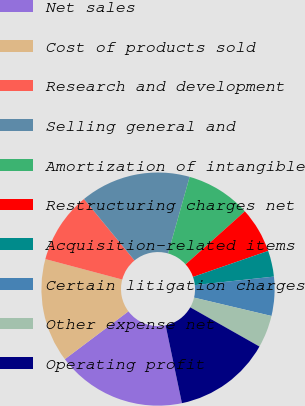<chart> <loc_0><loc_0><loc_500><loc_500><pie_chart><fcel>Net sales<fcel>Cost of products sold<fcel>Research and development<fcel>Selling general and<fcel>Amortization of intangible<fcel>Restructuring charges net<fcel>Acquisition-related items<fcel>Certain litigation charges<fcel>Other expense net<fcel>Operating profit<nl><fcel>18.02%<fcel>14.41%<fcel>9.91%<fcel>15.32%<fcel>9.01%<fcel>6.31%<fcel>3.6%<fcel>5.41%<fcel>4.5%<fcel>13.51%<nl></chart> 